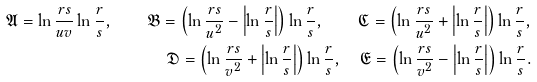<formula> <loc_0><loc_0><loc_500><loc_500>\mathfrak { A } = \ln \frac { r s } { u v } \ln \frac { r } s , \quad \mathfrak { B } = \left ( \ln \frac { r s } { u ^ { 2 } } - \left | \ln \frac { r } s \right | \right ) \ln \frac { r } s , \quad \mathfrak { C } = \left ( \ln \frac { r s } { u ^ { 2 } } + \left | \ln \frac { r } s \right | \right ) \ln \frac { r } s , \\ \mathfrak { D } = \left ( \ln \frac { r s } { v ^ { 2 } } + \left | \ln \frac { r } s \right | \right ) \ln \frac { r } s , \quad \mathfrak { E } = \left ( \ln \frac { r s } { v ^ { 2 } } - \left | \ln \frac { r } s \right | \right ) \ln \frac { r } s .</formula> 